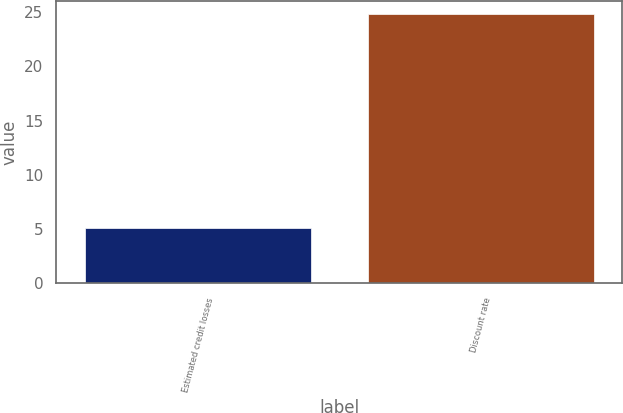Convert chart to OTSL. <chart><loc_0><loc_0><loc_500><loc_500><bar_chart><fcel>Estimated credit losses<fcel>Discount rate<nl><fcel>5.09<fcel>24.79<nl></chart> 